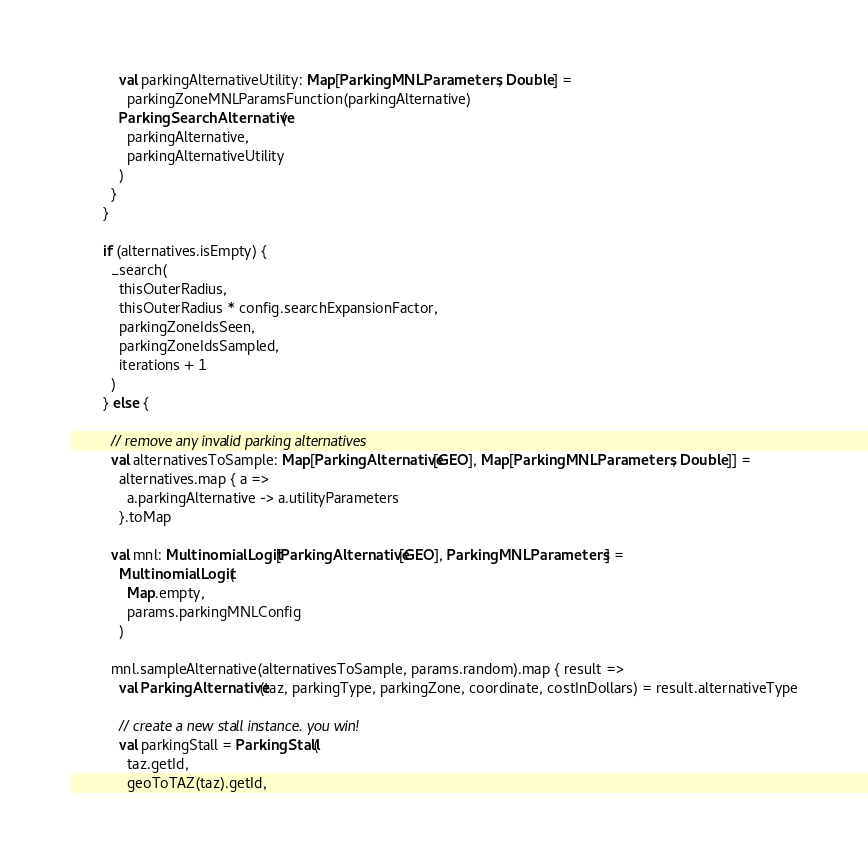<code> <loc_0><loc_0><loc_500><loc_500><_Scala_>            val parkingAlternativeUtility: Map[ParkingMNL.Parameters, Double] =
              parkingZoneMNLParamsFunction(parkingAlternative)
            ParkingSearchAlternative(
              parkingAlternative,
              parkingAlternativeUtility
            )
          }
        }

        if (alternatives.isEmpty) {
          _search(
            thisOuterRadius,
            thisOuterRadius * config.searchExpansionFactor,
            parkingZoneIdsSeen,
            parkingZoneIdsSampled,
            iterations + 1
          )
        } else {

          // remove any invalid parking alternatives
          val alternativesToSample: Map[ParkingAlternative[GEO], Map[ParkingMNL.Parameters, Double]] =
            alternatives.map { a =>
              a.parkingAlternative -> a.utilityParameters
            }.toMap

          val mnl: MultinomialLogit[ParkingAlternative[GEO], ParkingMNL.Parameters] =
            MultinomialLogit(
              Map.empty,
              params.parkingMNLConfig
            )

          mnl.sampleAlternative(alternativesToSample, params.random).map { result =>
            val ParkingAlternative(taz, parkingType, parkingZone, coordinate, costInDollars) = result.alternativeType

            // create a new stall instance. you win!
            val parkingStall = ParkingStall(
              taz.getId,
              geoToTAZ(taz).getId,</code> 